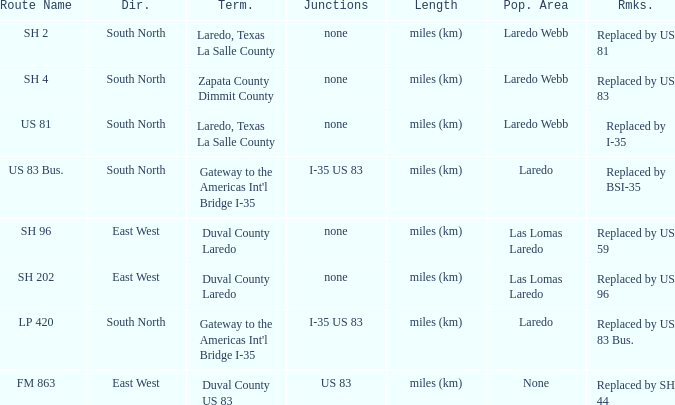How many junctions have "replaced by bsi-35" listed in their remarks section? 1.0. 